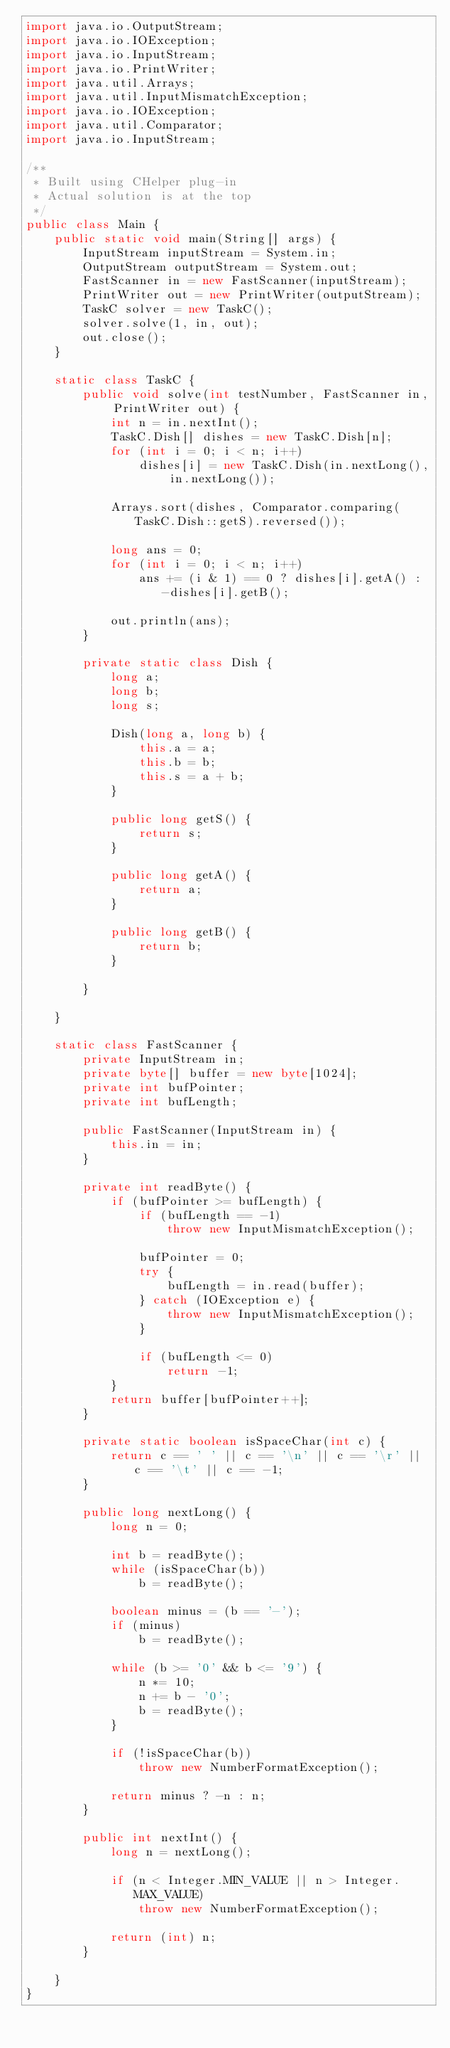Convert code to text. <code><loc_0><loc_0><loc_500><loc_500><_Java_>import java.io.OutputStream;
import java.io.IOException;
import java.io.InputStream;
import java.io.PrintWriter;
import java.util.Arrays;
import java.util.InputMismatchException;
import java.io.IOException;
import java.util.Comparator;
import java.io.InputStream;

/**
 * Built using CHelper plug-in
 * Actual solution is at the top
 */
public class Main {
    public static void main(String[] args) {
        InputStream inputStream = System.in;
        OutputStream outputStream = System.out;
        FastScanner in = new FastScanner(inputStream);
        PrintWriter out = new PrintWriter(outputStream);
        TaskC solver = new TaskC();
        solver.solve(1, in, out);
        out.close();
    }

    static class TaskC {
        public void solve(int testNumber, FastScanner in, PrintWriter out) {
            int n = in.nextInt();
            TaskC.Dish[] dishes = new TaskC.Dish[n];
            for (int i = 0; i < n; i++)
                dishes[i] = new TaskC.Dish(in.nextLong(), in.nextLong());

            Arrays.sort(dishes, Comparator.comparing(TaskC.Dish::getS).reversed());

            long ans = 0;
            for (int i = 0; i < n; i++)
                ans += (i & 1) == 0 ? dishes[i].getA() : -dishes[i].getB();

            out.println(ans);
        }

        private static class Dish {
            long a;
            long b;
            long s;

            Dish(long a, long b) {
                this.a = a;
                this.b = b;
                this.s = a + b;
            }

            public long getS() {
                return s;
            }

            public long getA() {
                return a;
            }

            public long getB() {
                return b;
            }

        }

    }

    static class FastScanner {
        private InputStream in;
        private byte[] buffer = new byte[1024];
        private int bufPointer;
        private int bufLength;

        public FastScanner(InputStream in) {
            this.in = in;
        }

        private int readByte() {
            if (bufPointer >= bufLength) {
                if (bufLength == -1)
                    throw new InputMismatchException();

                bufPointer = 0;
                try {
                    bufLength = in.read(buffer);
                } catch (IOException e) {
                    throw new InputMismatchException();
                }

                if (bufLength <= 0)
                    return -1;
            }
            return buffer[bufPointer++];
        }

        private static boolean isSpaceChar(int c) {
            return c == ' ' || c == '\n' || c == '\r' || c == '\t' || c == -1;
        }

        public long nextLong() {
            long n = 0;

            int b = readByte();
            while (isSpaceChar(b))
                b = readByte();

            boolean minus = (b == '-');
            if (minus)
                b = readByte();

            while (b >= '0' && b <= '9') {
                n *= 10;
                n += b - '0';
                b = readByte();
            }

            if (!isSpaceChar(b))
                throw new NumberFormatException();

            return minus ? -n : n;
        }

        public int nextInt() {
            long n = nextLong();

            if (n < Integer.MIN_VALUE || n > Integer.MAX_VALUE)
                throw new NumberFormatException();

            return (int) n;
        }

    }
}

</code> 